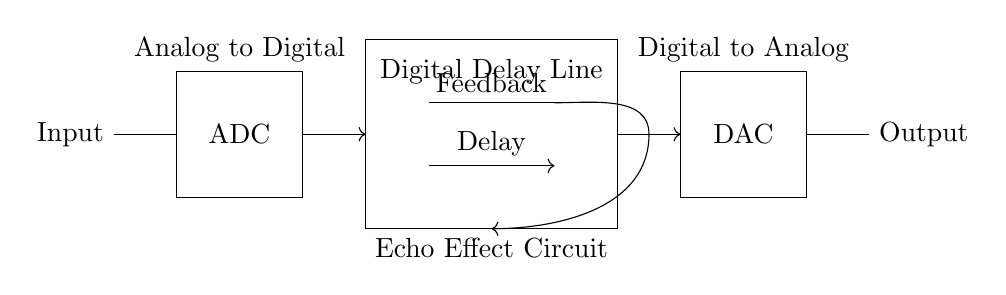What component converts analog audio signals to digital? The component that performs this function is labeled as "ADC" in the circuit, which stands for Analog to Digital Converter. It processes the analog input signal and converts it into a digital format for further processing.
Answer: ADC What is the purpose of the Digital Delay Line? The Digital Delay Line is designed to introduce a delay to the audio signal, allowing for the creation of echo effects which can enhance musical compositions. This is indicated by the label "Digital Delay Line" and the arrows showing the signal flow into and from it.
Answer: Echo effect How many main components are there in this circuit? The main components present in the circuit are the ADC, Digital Delay Line, and DAC, totaling three main parts. This can be counted easily by identifying each distinct labeled section of the circuit diagram.
Answer: Three What is the output of the DAC component? The output of the DAC, which is labeled as "Output" in the circuit, is the digital signal that has been converted back into an analog format. This is essential for the final audio output to be played back through speakers or headphones.
Answer: Output What allows feedback in this circuit? The feedback in this circuit is facilitated by the connection labeled "Feedback," which shows a flow from the delay line back into the circuit. This connection allows part of the output signal to be reintroduced to the input, enhancing the echo effect.
Answer: Feedback 